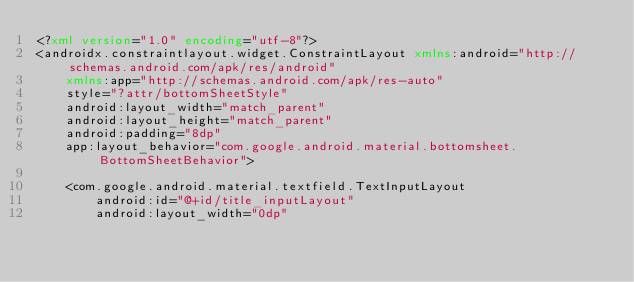<code> <loc_0><loc_0><loc_500><loc_500><_XML_><?xml version="1.0" encoding="utf-8"?>
<androidx.constraintlayout.widget.ConstraintLayout xmlns:android="http://schemas.android.com/apk/res/android"
    xmlns:app="http://schemas.android.com/apk/res-auto"
    style="?attr/bottomSheetStyle"
    android:layout_width="match_parent"
    android:layout_height="match_parent"
    android:padding="8dp"
    app:layout_behavior="com.google.android.material.bottomsheet.BottomSheetBehavior">

    <com.google.android.material.textfield.TextInputLayout
        android:id="@+id/title_inputLayout"
        android:layout_width="0dp"</code> 